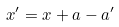Convert formula to latex. <formula><loc_0><loc_0><loc_500><loc_500>x ^ { \prime } = x + a - a ^ { \prime }</formula> 